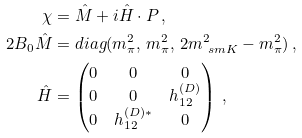Convert formula to latex. <formula><loc_0><loc_0><loc_500><loc_500>\chi & = \hat { M } + i \hat { H } \cdot P \, , \\ 2 B _ { 0 } \hat { M } & = d i a g ( m _ { \pi } ^ { 2 } , \, m _ { \pi } ^ { 2 } , \, 2 m _ { \ s m K } ^ { 2 } - m _ { \pi } ^ { 2 } ) \, , \\ \hat { H } & = \begin{pmatrix} 0 & 0 & 0 \\ 0 & 0 & h _ { 1 2 } ^ { ( D ) } \\ 0 & h _ { 1 2 } ^ { ( D ) * } & 0 \end{pmatrix} \, ,</formula> 